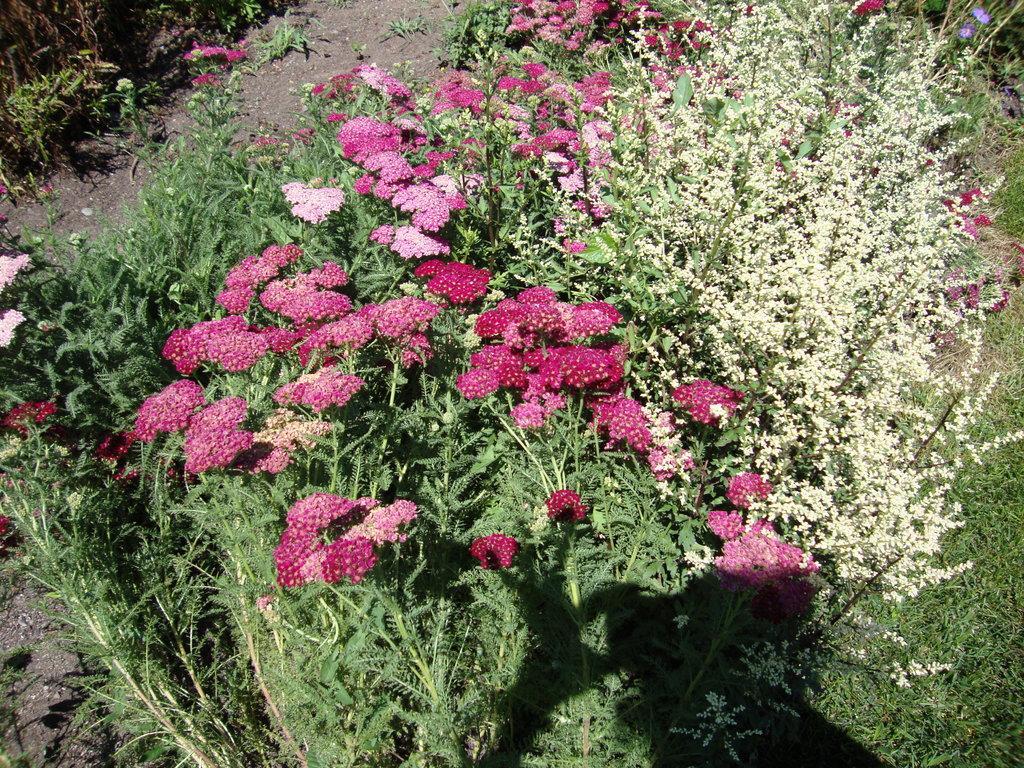How would you summarize this image in a sentence or two? In the picture I can see pink color flowers of a plant and here I can see a few more plants. 